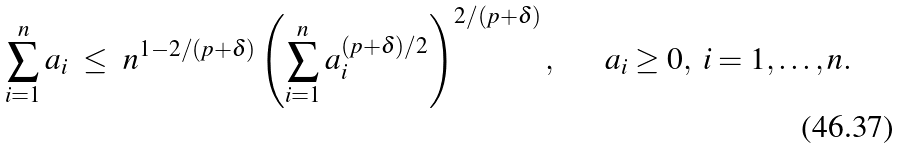Convert formula to latex. <formula><loc_0><loc_0><loc_500><loc_500>\sum _ { i = 1 } ^ { n } a _ { i } \ \leq \ n ^ { 1 - 2 / ( p + \delta ) } \left ( \sum _ { i = 1 } ^ { n } a _ { i } ^ { ( p + \delta ) / 2 } \right ) ^ { 2 / ( p + \delta ) } , \quad \ \ a _ { i } \geq 0 , \ i = 1 , \dots , n .</formula> 